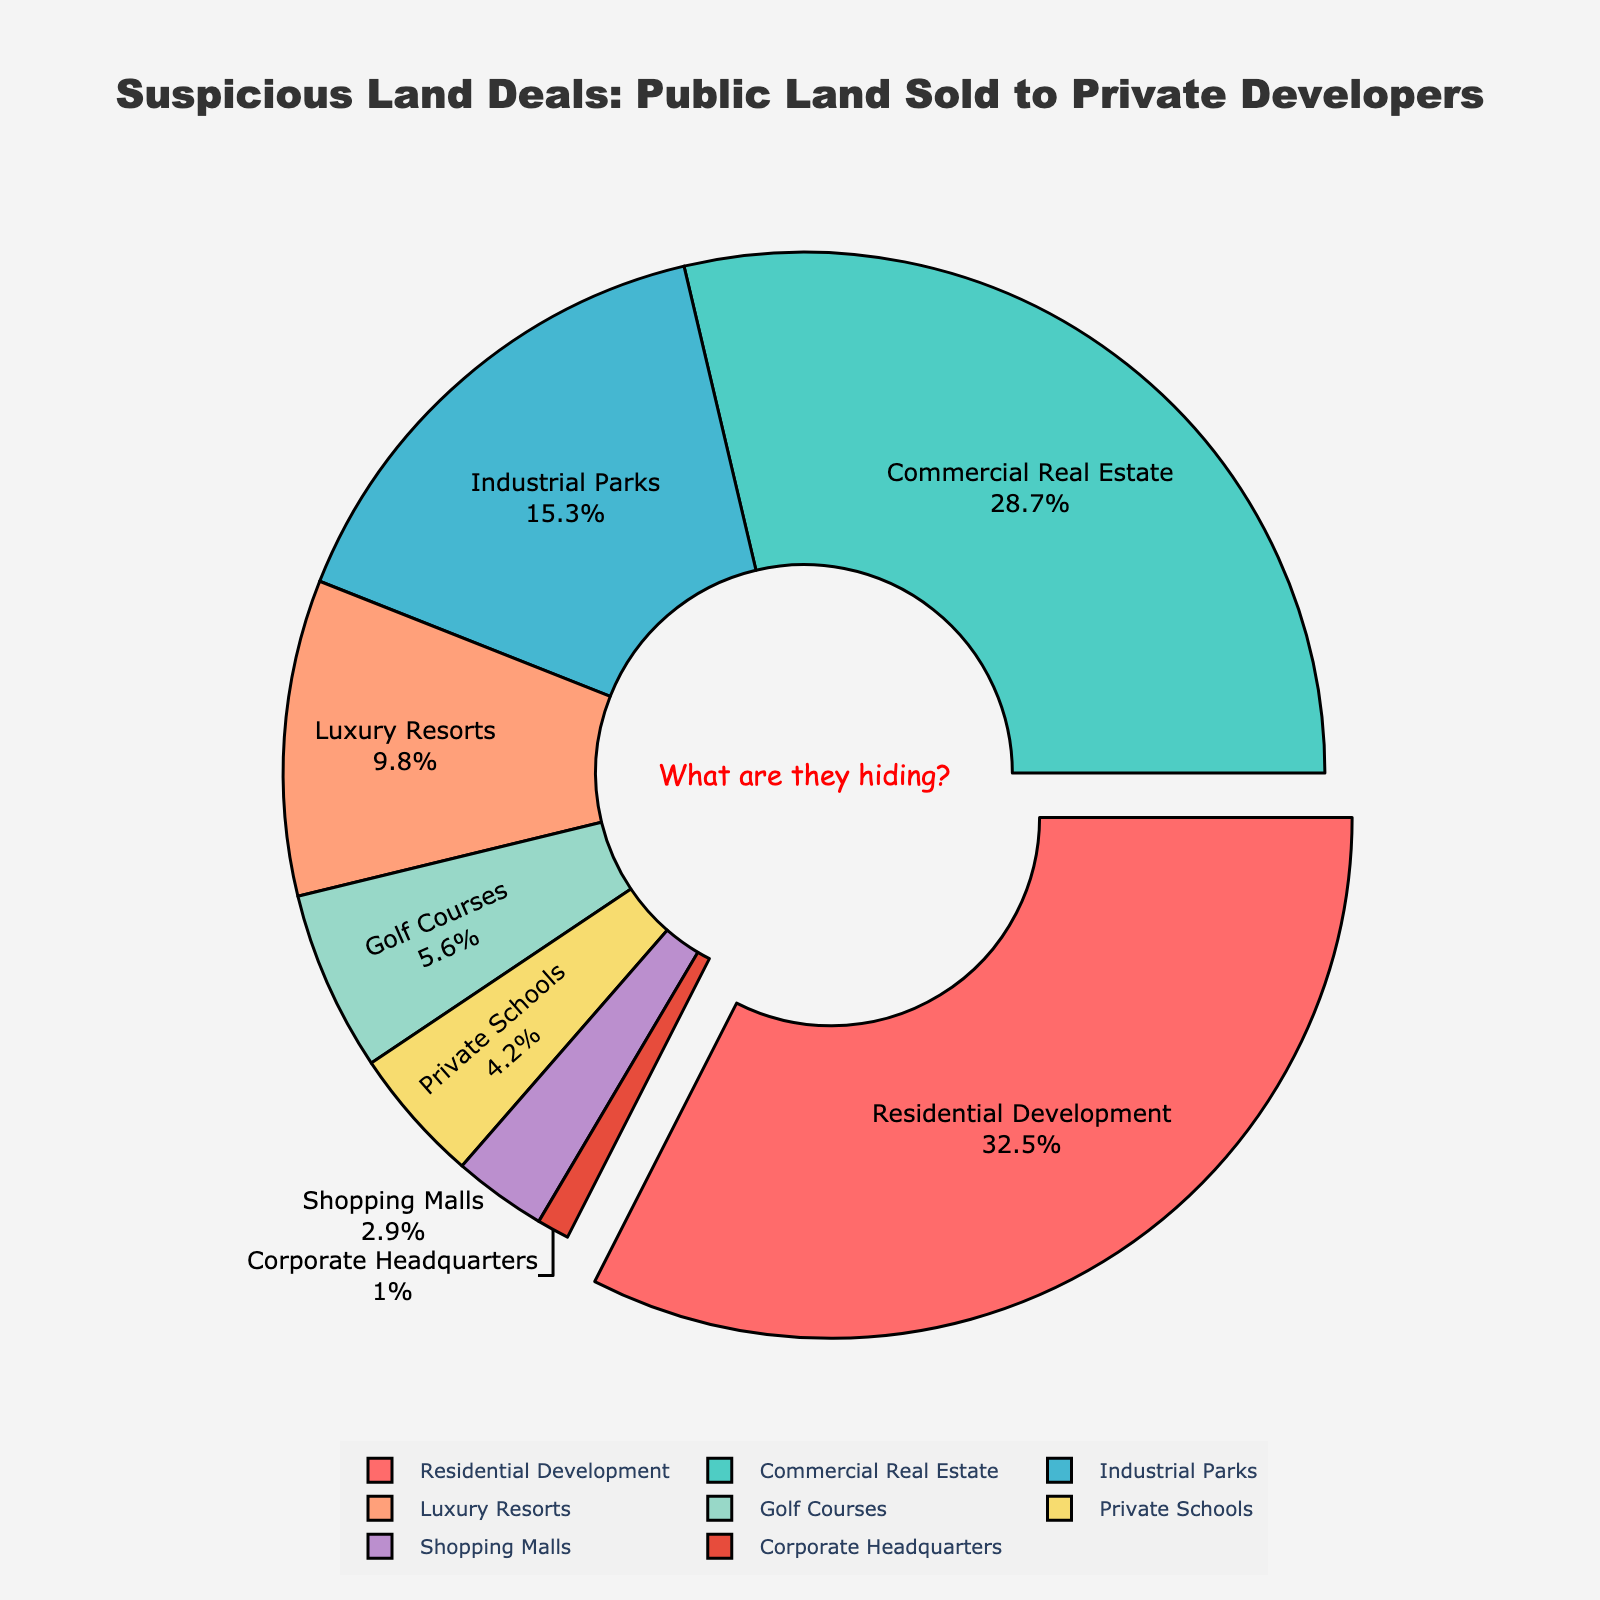What is the category with the highest percentage of public land sold to private developers? The category with the highest percentage of public land sold to private developers is "Residential Development." This category is shown as the largest slice of the pie chart, which is also slightly pulled out to emphasize it.
Answer: Residential Development Which two categories together constitute more than 50% of the total public land sold to private developers? By adding the percentages of "Residential Development" (32.5%) and "Commercial Real Estate" (28.7%), we get 32.5% + 28.7% = 61.2%, which is more than 50%.
Answer: Residential Development and Commercial Real Estate What is the combined percentage of public land sold to "Golf Courses" and "Private Schools"? The combined percentage of public land sold to "Golf Courses" and "Private Schools" is calculated by adding their respective percentages: 5.6% + 4.2% = 9.8%.
Answer: 9.8% Which category is represented by the color red in the pie chart? The category represented by the color red is "Residential Development." This is evident as the pie slice for "Residential Development" is visually highlighted and pulled out, and it is colored red.
Answer: Residential Development How much more public land (in percentage) is sold to "Industrial Parks" compared to "Private Schools"? The percentage of public land sold to "Industrial Parks" is 15.3%, and to "Private Schools" it is 4.2%. The difference is calculated as 15.3% - 4.2% = 11.1%.
Answer: 11.1% Which categories together make up less than 10% of the total public land sold? The categories "Shopping Malls" (2.9%) and "Corporate Headquarters" (1.0%) together make up 2.9% + 1.0% = 3.9%, which is less than 10%.
Answer: Shopping Malls and Corporate Headquarters What is the percentage difference between the land sold for "Luxury Resorts" and "Commercial Real Estate"? The percentage of public land sold to "Luxury Resorts" is 9.8%, and to "Commercial Real Estate" is 28.7%. The difference is calculated as 28.7% - 9.8% = 18.9%.
Answer: 18.9% What color represents the category with the smallest percentage of public land sold? The smallest percentage of public land sold is to "Corporate Headquarters" at 1.0%, and it is represented by the color pink (use a similar natural term if exact colors are not visually distinct).
Answer: Pink Based on the annotations, what is the potential implication suggested by the pie chart about the sales of public land? The annotation "What are they hiding?" suggests a suspicion or implication that there might be hidden motives or lack of transparency regarding the sales of public land.
Answer: Hidden motives Which category has approximately one-third of the total percentage of public land sold to private developers? The category "Residential Development" accounts for 32.5% of the total public land sold, which is approximately one-third of the total percentage.
Answer: Residential Development 